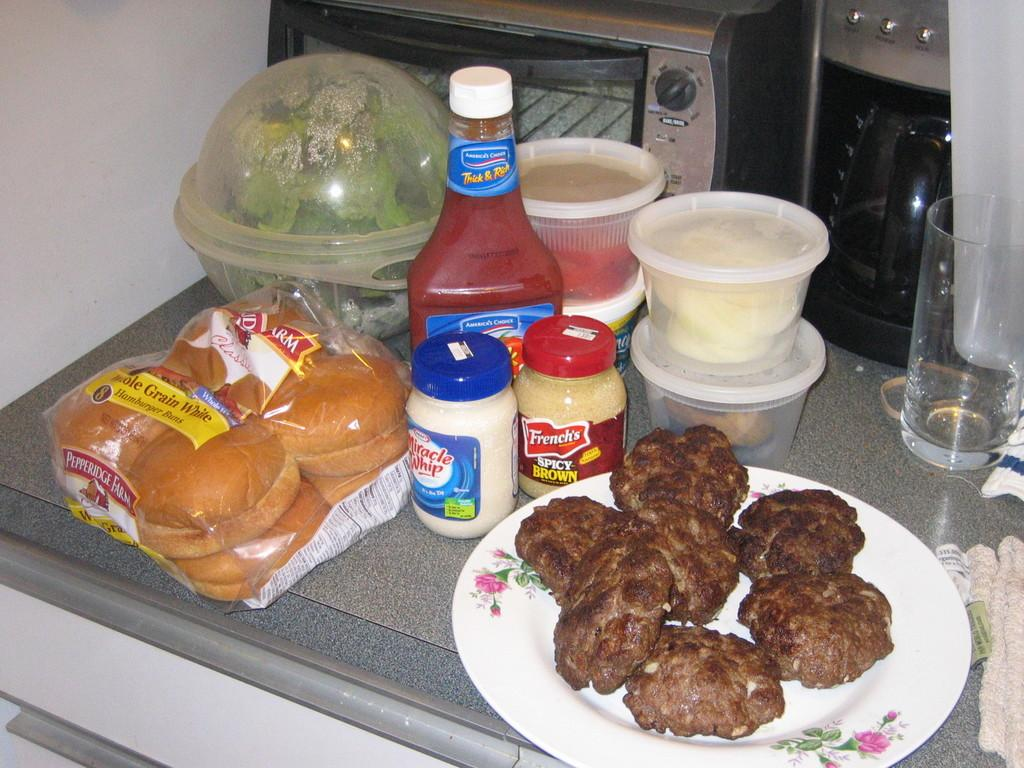What type of food items can be seen in the image? There are buns, creams, sauces, and other food items in the image. What is the material of the floor in the image? The floor is made of marble. What cooking appliance is visible in the image? There is an oven behind the food items. What is happening on the right side of the image? There is a class on the right side of the image. What color is the orange that is being used as a prop in the class? There is no orange present in the image; it only features food items, an oven, and a class. 